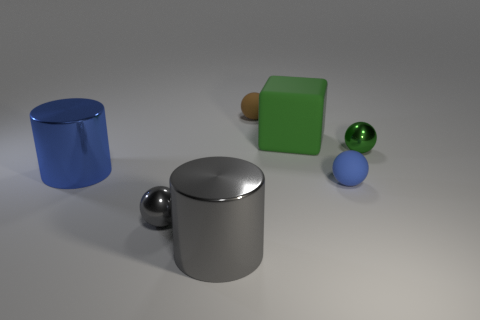Subtract 1 balls. How many balls are left? 3 Add 2 matte spheres. How many objects exist? 9 Subtract all cylinders. How many objects are left? 5 Subtract all tiny cyan rubber cylinders. Subtract all brown spheres. How many objects are left? 6 Add 7 small green objects. How many small green objects are left? 8 Add 5 big shiny things. How many big shiny things exist? 7 Subtract 0 cyan balls. How many objects are left? 7 